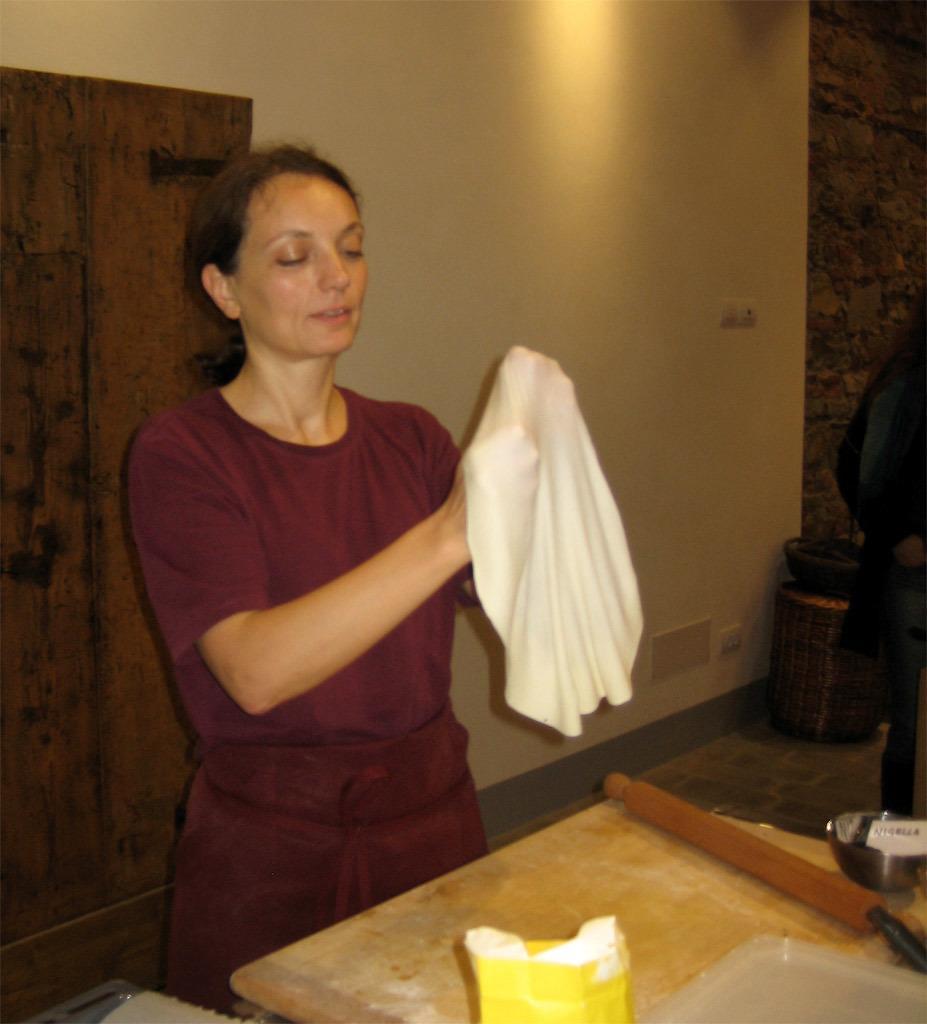Can you describe this image briefly? In this picture we can see a woman standing and holding a flattened dough in her hands. In front of her we can see a wooden surface and flour packet. 